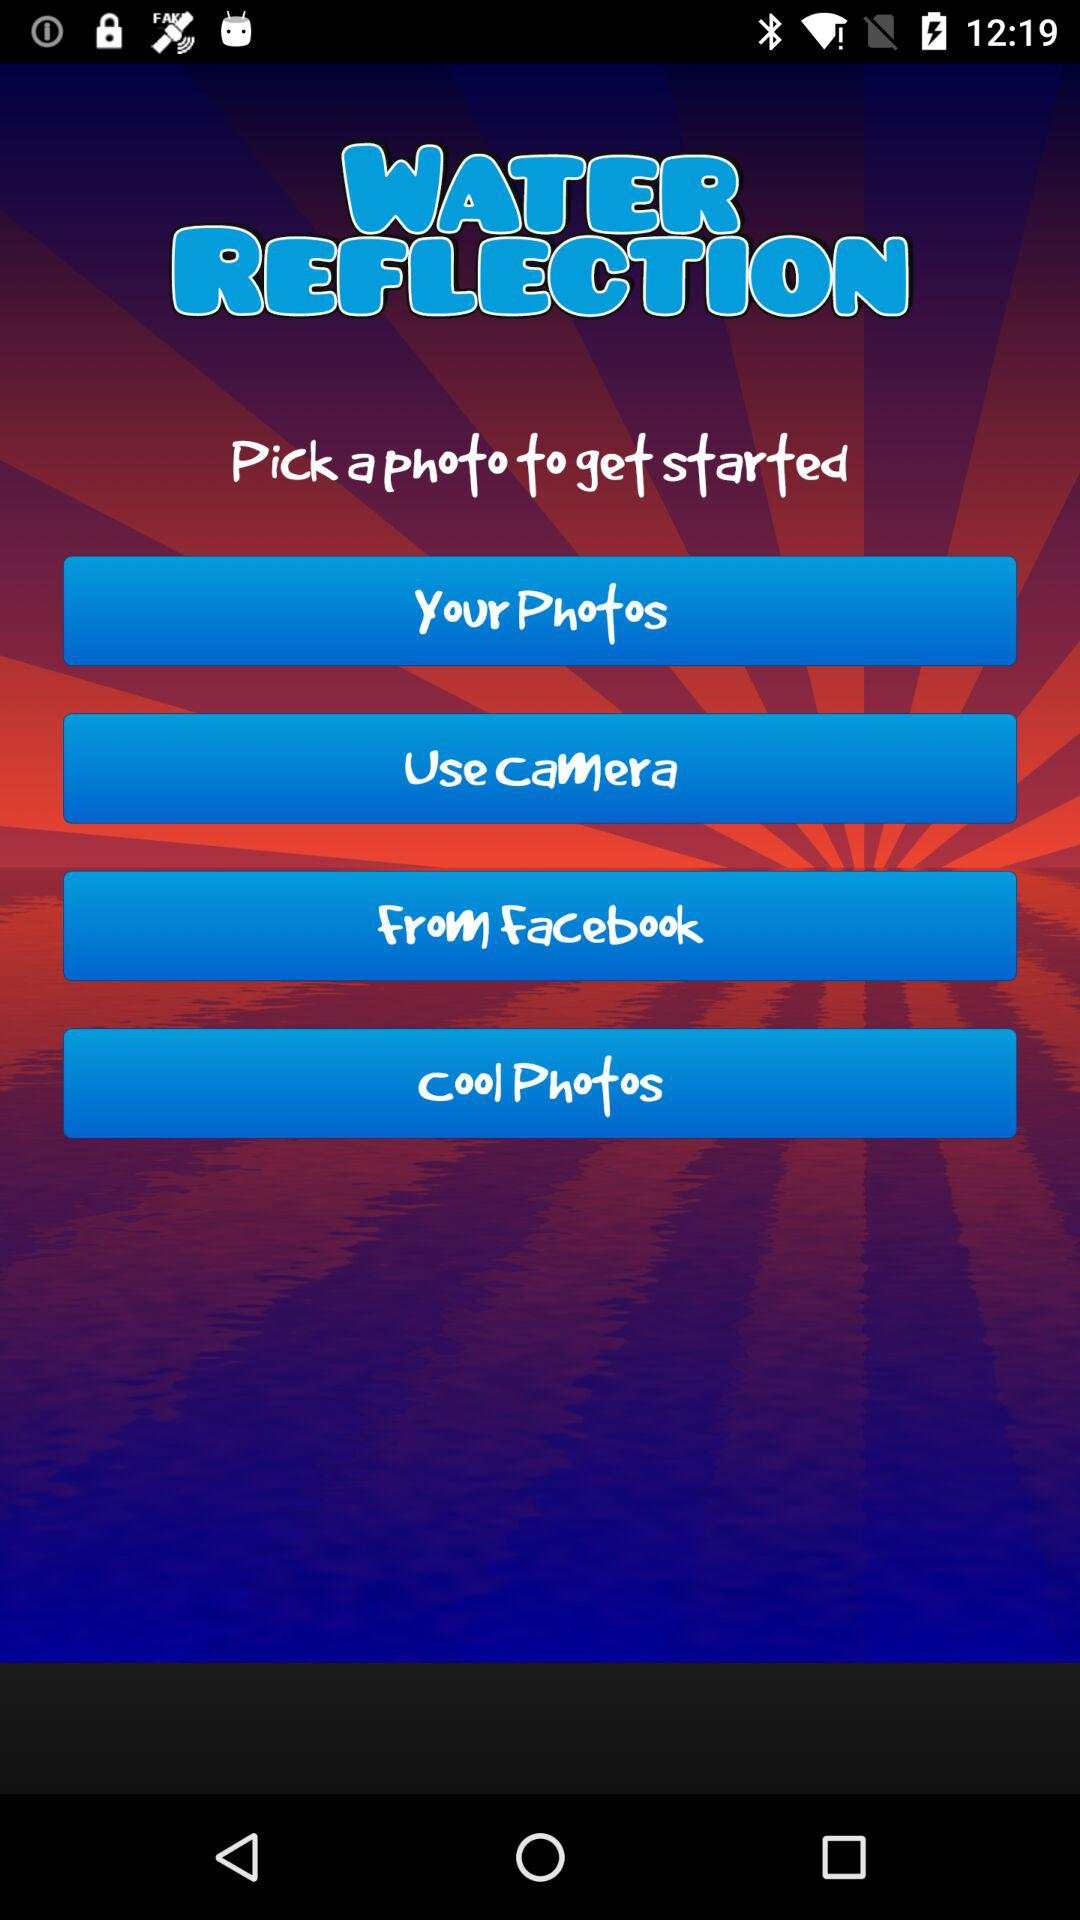What options can I use to pick a photo? The options that you can use to pick a photo are "Your Photos", "Use Camera", "From Facebook" and "Cool Photos". 